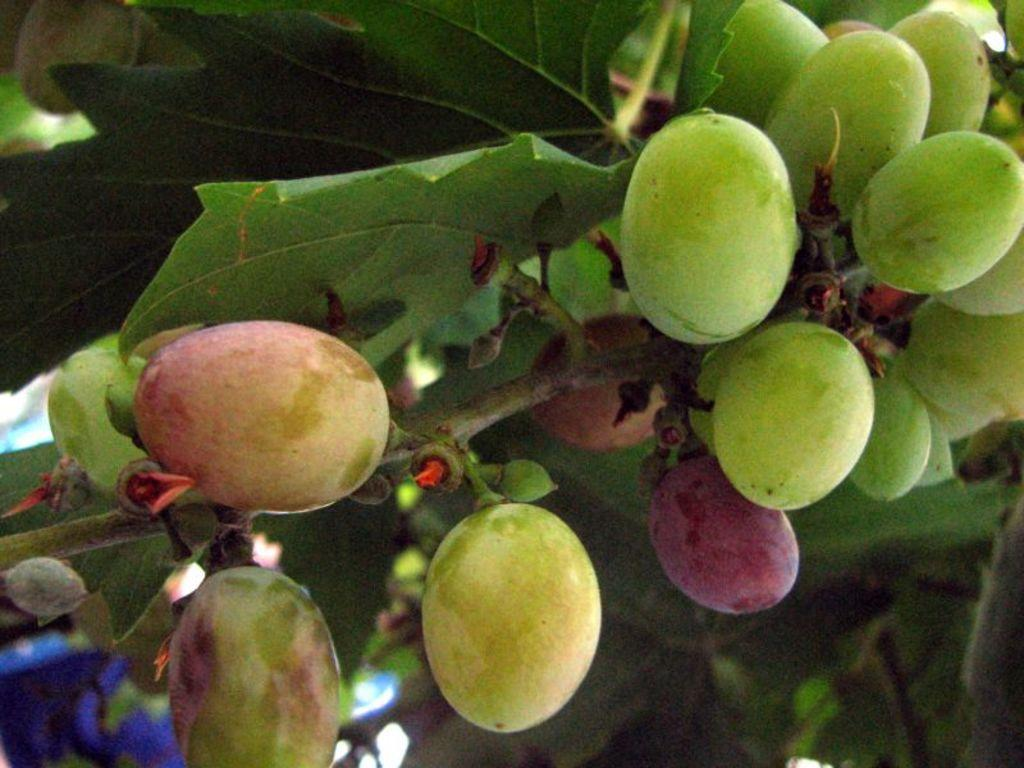What is present in the image? There is a tree in the image. What can be said about the color of the tree? The tree is green in color. What is growing on the tree? There are fruits on the tree. What colors are the fruits? The fruits are green and pink in color. How many sheep are visible in the image? There are no sheep present in the image. What type of breakfast is being served in the image? There is no breakfast visible in the image. 